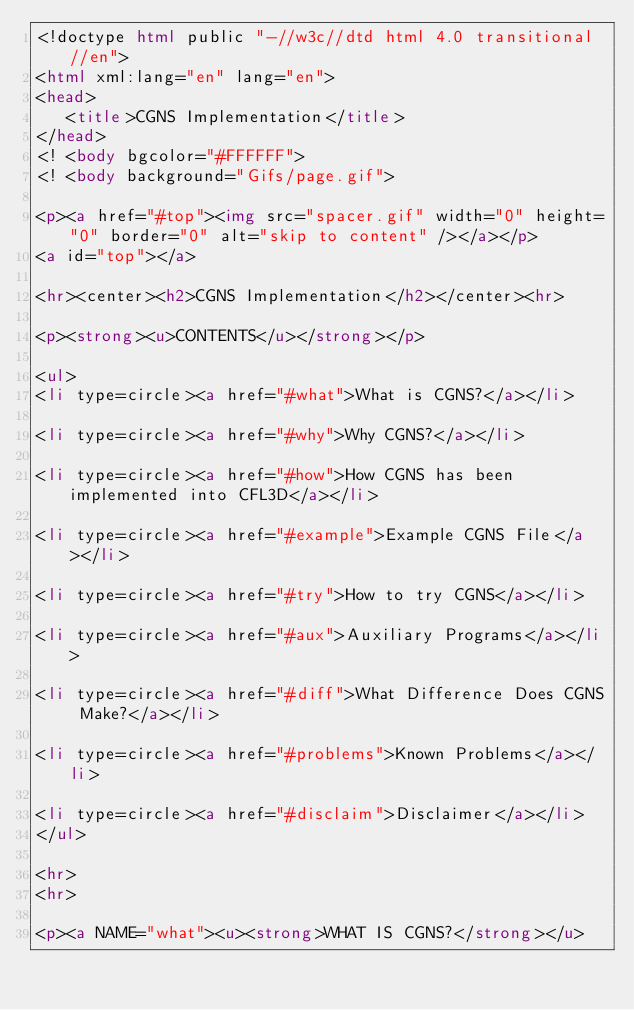<code> <loc_0><loc_0><loc_500><loc_500><_HTML_><!doctype html public "-//w3c//dtd html 4.0 transitional//en">
<html xml:lang="en" lang="en">
<head>
   <title>CGNS Implementation</title>
</head>
<! <body bgcolor="#FFFFFF">
<! <body background="Gifs/page.gif">

<p><a href="#top"><img src="spacer.gif" width="0" height="0" border="0" alt="skip to content" /></a></p>
<a id="top"></a>

<hr><center><h2>CGNS Implementation</h2></center><hr>

<p><strong><u>CONTENTS</u></strong></p>

<ul>
<li type=circle><a href="#what">What is CGNS?</a></li>

<li type=circle><a href="#why">Why CGNS?</a></li>

<li type=circle><a href="#how">How CGNS has been implemented into CFL3D</a></li>

<li type=circle><a href="#example">Example CGNS File</a></li>

<li type=circle><a href="#try">How to try CGNS</a></li>

<li type=circle><a href="#aux">Auxiliary Programs</a></li>

<li type=circle><a href="#diff">What Difference Does CGNS Make?</a></li>

<li type=circle><a href="#problems">Known Problems</a></li>

<li type=circle><a href="#disclaim">Disclaimer</a></li>
</ul>

<hr>
<hr>

<p><a NAME="what"><u><strong>WHAT IS CGNS?</strong></u>
</code> 